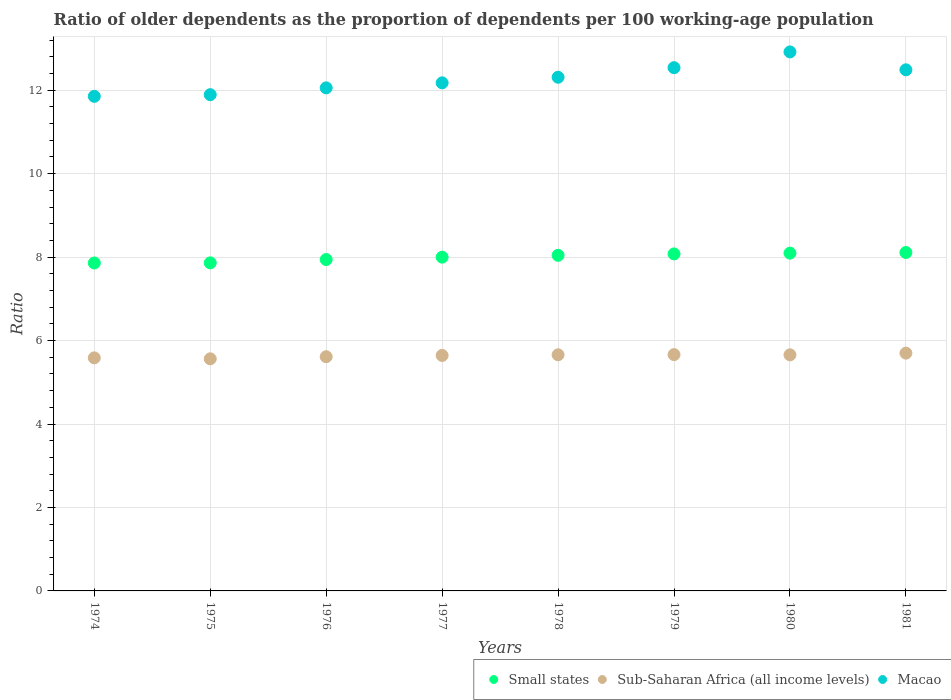How many different coloured dotlines are there?
Your answer should be compact. 3. Is the number of dotlines equal to the number of legend labels?
Offer a terse response. Yes. What is the age dependency ratio(old) in Macao in 1975?
Offer a very short reply. 11.89. Across all years, what is the maximum age dependency ratio(old) in Sub-Saharan Africa (all income levels)?
Make the answer very short. 5.7. Across all years, what is the minimum age dependency ratio(old) in Sub-Saharan Africa (all income levels)?
Ensure brevity in your answer.  5.56. In which year was the age dependency ratio(old) in Sub-Saharan Africa (all income levels) minimum?
Provide a short and direct response. 1975. What is the total age dependency ratio(old) in Sub-Saharan Africa (all income levels) in the graph?
Offer a terse response. 45.08. What is the difference between the age dependency ratio(old) in Sub-Saharan Africa (all income levels) in 1977 and that in 1980?
Your answer should be compact. -0.01. What is the difference between the age dependency ratio(old) in Sub-Saharan Africa (all income levels) in 1981 and the age dependency ratio(old) in Small states in 1974?
Give a very brief answer. -2.16. What is the average age dependency ratio(old) in Macao per year?
Your response must be concise. 12.28. In the year 1978, what is the difference between the age dependency ratio(old) in Sub-Saharan Africa (all income levels) and age dependency ratio(old) in Macao?
Provide a short and direct response. -6.65. What is the ratio of the age dependency ratio(old) in Small states in 1976 to that in 1979?
Your answer should be very brief. 0.98. Is the difference between the age dependency ratio(old) in Sub-Saharan Africa (all income levels) in 1979 and 1980 greater than the difference between the age dependency ratio(old) in Macao in 1979 and 1980?
Provide a succinct answer. Yes. What is the difference between the highest and the second highest age dependency ratio(old) in Sub-Saharan Africa (all income levels)?
Your answer should be very brief. 0.04. What is the difference between the highest and the lowest age dependency ratio(old) in Small states?
Offer a terse response. 0.25. In how many years, is the age dependency ratio(old) in Macao greater than the average age dependency ratio(old) in Macao taken over all years?
Ensure brevity in your answer.  4. Is the sum of the age dependency ratio(old) in Sub-Saharan Africa (all income levels) in 1974 and 1980 greater than the maximum age dependency ratio(old) in Small states across all years?
Keep it short and to the point. Yes. Is it the case that in every year, the sum of the age dependency ratio(old) in Sub-Saharan Africa (all income levels) and age dependency ratio(old) in Macao  is greater than the age dependency ratio(old) in Small states?
Ensure brevity in your answer.  Yes. Does the age dependency ratio(old) in Small states monotonically increase over the years?
Keep it short and to the point. Yes. Is the age dependency ratio(old) in Sub-Saharan Africa (all income levels) strictly greater than the age dependency ratio(old) in Small states over the years?
Give a very brief answer. No. How many years are there in the graph?
Provide a succinct answer. 8. Where does the legend appear in the graph?
Your answer should be very brief. Bottom right. How are the legend labels stacked?
Give a very brief answer. Horizontal. What is the title of the graph?
Keep it short and to the point. Ratio of older dependents as the proportion of dependents per 100 working-age population. Does "Other small states" appear as one of the legend labels in the graph?
Make the answer very short. No. What is the label or title of the X-axis?
Your answer should be compact. Years. What is the label or title of the Y-axis?
Offer a very short reply. Ratio. What is the Ratio in Small states in 1974?
Make the answer very short. 7.86. What is the Ratio of Sub-Saharan Africa (all income levels) in 1974?
Offer a terse response. 5.59. What is the Ratio of Macao in 1974?
Provide a succinct answer. 11.85. What is the Ratio in Small states in 1975?
Your response must be concise. 7.86. What is the Ratio in Sub-Saharan Africa (all income levels) in 1975?
Offer a very short reply. 5.56. What is the Ratio of Macao in 1975?
Your response must be concise. 11.89. What is the Ratio in Small states in 1976?
Provide a succinct answer. 7.94. What is the Ratio of Sub-Saharan Africa (all income levels) in 1976?
Give a very brief answer. 5.61. What is the Ratio of Macao in 1976?
Offer a very short reply. 12.06. What is the Ratio in Small states in 1977?
Provide a succinct answer. 8. What is the Ratio in Sub-Saharan Africa (all income levels) in 1977?
Make the answer very short. 5.64. What is the Ratio of Macao in 1977?
Provide a short and direct response. 12.18. What is the Ratio of Small states in 1978?
Your answer should be compact. 8.04. What is the Ratio of Sub-Saharan Africa (all income levels) in 1978?
Offer a very short reply. 5.66. What is the Ratio of Macao in 1978?
Your answer should be compact. 12.31. What is the Ratio of Small states in 1979?
Keep it short and to the point. 8.08. What is the Ratio in Sub-Saharan Africa (all income levels) in 1979?
Your answer should be compact. 5.66. What is the Ratio of Macao in 1979?
Offer a terse response. 12.54. What is the Ratio in Small states in 1980?
Keep it short and to the point. 8.1. What is the Ratio of Sub-Saharan Africa (all income levels) in 1980?
Ensure brevity in your answer.  5.66. What is the Ratio of Macao in 1980?
Provide a short and direct response. 12.92. What is the Ratio in Small states in 1981?
Give a very brief answer. 8.11. What is the Ratio in Sub-Saharan Africa (all income levels) in 1981?
Ensure brevity in your answer.  5.7. What is the Ratio of Macao in 1981?
Offer a terse response. 12.49. Across all years, what is the maximum Ratio of Small states?
Provide a short and direct response. 8.11. Across all years, what is the maximum Ratio in Sub-Saharan Africa (all income levels)?
Your answer should be compact. 5.7. Across all years, what is the maximum Ratio in Macao?
Give a very brief answer. 12.92. Across all years, what is the minimum Ratio in Small states?
Keep it short and to the point. 7.86. Across all years, what is the minimum Ratio of Sub-Saharan Africa (all income levels)?
Offer a terse response. 5.56. Across all years, what is the minimum Ratio in Macao?
Ensure brevity in your answer.  11.85. What is the total Ratio in Small states in the graph?
Give a very brief answer. 63.99. What is the total Ratio of Sub-Saharan Africa (all income levels) in the graph?
Your response must be concise. 45.08. What is the total Ratio of Macao in the graph?
Your answer should be compact. 98.24. What is the difference between the Ratio of Small states in 1974 and that in 1975?
Your answer should be compact. -0. What is the difference between the Ratio of Sub-Saharan Africa (all income levels) in 1974 and that in 1975?
Provide a succinct answer. 0.02. What is the difference between the Ratio in Macao in 1974 and that in 1975?
Offer a very short reply. -0.04. What is the difference between the Ratio in Small states in 1974 and that in 1976?
Offer a terse response. -0.08. What is the difference between the Ratio of Sub-Saharan Africa (all income levels) in 1974 and that in 1976?
Offer a terse response. -0.03. What is the difference between the Ratio of Macao in 1974 and that in 1976?
Give a very brief answer. -0.2. What is the difference between the Ratio in Small states in 1974 and that in 1977?
Your response must be concise. -0.14. What is the difference between the Ratio in Sub-Saharan Africa (all income levels) in 1974 and that in 1977?
Your answer should be very brief. -0.06. What is the difference between the Ratio of Macao in 1974 and that in 1977?
Offer a very short reply. -0.32. What is the difference between the Ratio of Small states in 1974 and that in 1978?
Keep it short and to the point. -0.18. What is the difference between the Ratio in Sub-Saharan Africa (all income levels) in 1974 and that in 1978?
Make the answer very short. -0.07. What is the difference between the Ratio of Macao in 1974 and that in 1978?
Offer a terse response. -0.46. What is the difference between the Ratio of Small states in 1974 and that in 1979?
Keep it short and to the point. -0.22. What is the difference between the Ratio of Sub-Saharan Africa (all income levels) in 1974 and that in 1979?
Offer a terse response. -0.08. What is the difference between the Ratio of Macao in 1974 and that in 1979?
Your answer should be very brief. -0.69. What is the difference between the Ratio of Small states in 1974 and that in 1980?
Make the answer very short. -0.24. What is the difference between the Ratio in Sub-Saharan Africa (all income levels) in 1974 and that in 1980?
Your answer should be compact. -0.07. What is the difference between the Ratio in Macao in 1974 and that in 1980?
Give a very brief answer. -1.06. What is the difference between the Ratio in Small states in 1974 and that in 1981?
Offer a terse response. -0.25. What is the difference between the Ratio of Sub-Saharan Africa (all income levels) in 1974 and that in 1981?
Offer a terse response. -0.11. What is the difference between the Ratio of Macao in 1974 and that in 1981?
Your response must be concise. -0.64. What is the difference between the Ratio of Small states in 1975 and that in 1976?
Provide a succinct answer. -0.08. What is the difference between the Ratio in Sub-Saharan Africa (all income levels) in 1975 and that in 1976?
Provide a succinct answer. -0.05. What is the difference between the Ratio of Macao in 1975 and that in 1976?
Your answer should be very brief. -0.16. What is the difference between the Ratio of Small states in 1975 and that in 1977?
Provide a short and direct response. -0.14. What is the difference between the Ratio in Sub-Saharan Africa (all income levels) in 1975 and that in 1977?
Give a very brief answer. -0.08. What is the difference between the Ratio in Macao in 1975 and that in 1977?
Ensure brevity in your answer.  -0.28. What is the difference between the Ratio in Small states in 1975 and that in 1978?
Your answer should be very brief. -0.18. What is the difference between the Ratio of Sub-Saharan Africa (all income levels) in 1975 and that in 1978?
Offer a terse response. -0.1. What is the difference between the Ratio of Macao in 1975 and that in 1978?
Your answer should be very brief. -0.42. What is the difference between the Ratio in Small states in 1975 and that in 1979?
Give a very brief answer. -0.21. What is the difference between the Ratio in Sub-Saharan Africa (all income levels) in 1975 and that in 1979?
Provide a succinct answer. -0.1. What is the difference between the Ratio in Macao in 1975 and that in 1979?
Keep it short and to the point. -0.65. What is the difference between the Ratio in Small states in 1975 and that in 1980?
Offer a terse response. -0.23. What is the difference between the Ratio of Sub-Saharan Africa (all income levels) in 1975 and that in 1980?
Offer a very short reply. -0.1. What is the difference between the Ratio of Macao in 1975 and that in 1980?
Give a very brief answer. -1.02. What is the difference between the Ratio in Small states in 1975 and that in 1981?
Provide a short and direct response. -0.25. What is the difference between the Ratio in Sub-Saharan Africa (all income levels) in 1975 and that in 1981?
Keep it short and to the point. -0.14. What is the difference between the Ratio in Macao in 1975 and that in 1981?
Your answer should be very brief. -0.6. What is the difference between the Ratio in Small states in 1976 and that in 1977?
Your answer should be compact. -0.06. What is the difference between the Ratio of Sub-Saharan Africa (all income levels) in 1976 and that in 1977?
Provide a short and direct response. -0.03. What is the difference between the Ratio of Macao in 1976 and that in 1977?
Keep it short and to the point. -0.12. What is the difference between the Ratio in Small states in 1976 and that in 1978?
Make the answer very short. -0.1. What is the difference between the Ratio of Sub-Saharan Africa (all income levels) in 1976 and that in 1978?
Keep it short and to the point. -0.05. What is the difference between the Ratio of Macao in 1976 and that in 1978?
Your answer should be compact. -0.25. What is the difference between the Ratio of Small states in 1976 and that in 1979?
Your response must be concise. -0.14. What is the difference between the Ratio of Sub-Saharan Africa (all income levels) in 1976 and that in 1979?
Offer a very short reply. -0.05. What is the difference between the Ratio of Macao in 1976 and that in 1979?
Give a very brief answer. -0.48. What is the difference between the Ratio in Small states in 1976 and that in 1980?
Your response must be concise. -0.15. What is the difference between the Ratio of Sub-Saharan Africa (all income levels) in 1976 and that in 1980?
Provide a succinct answer. -0.04. What is the difference between the Ratio of Macao in 1976 and that in 1980?
Offer a terse response. -0.86. What is the difference between the Ratio in Small states in 1976 and that in 1981?
Your response must be concise. -0.17. What is the difference between the Ratio of Sub-Saharan Africa (all income levels) in 1976 and that in 1981?
Provide a short and direct response. -0.09. What is the difference between the Ratio in Macao in 1976 and that in 1981?
Keep it short and to the point. -0.43. What is the difference between the Ratio in Small states in 1977 and that in 1978?
Your answer should be compact. -0.04. What is the difference between the Ratio of Sub-Saharan Africa (all income levels) in 1977 and that in 1978?
Give a very brief answer. -0.02. What is the difference between the Ratio in Macao in 1977 and that in 1978?
Your response must be concise. -0.13. What is the difference between the Ratio in Small states in 1977 and that in 1979?
Provide a succinct answer. -0.08. What is the difference between the Ratio of Sub-Saharan Africa (all income levels) in 1977 and that in 1979?
Your answer should be very brief. -0.02. What is the difference between the Ratio of Macao in 1977 and that in 1979?
Provide a short and direct response. -0.36. What is the difference between the Ratio of Small states in 1977 and that in 1980?
Your response must be concise. -0.1. What is the difference between the Ratio of Sub-Saharan Africa (all income levels) in 1977 and that in 1980?
Your answer should be very brief. -0.01. What is the difference between the Ratio in Macao in 1977 and that in 1980?
Give a very brief answer. -0.74. What is the difference between the Ratio of Small states in 1977 and that in 1981?
Your response must be concise. -0.11. What is the difference between the Ratio in Sub-Saharan Africa (all income levels) in 1977 and that in 1981?
Your answer should be very brief. -0.06. What is the difference between the Ratio of Macao in 1977 and that in 1981?
Your answer should be very brief. -0.31. What is the difference between the Ratio of Small states in 1978 and that in 1979?
Your answer should be very brief. -0.03. What is the difference between the Ratio of Sub-Saharan Africa (all income levels) in 1978 and that in 1979?
Your response must be concise. -0. What is the difference between the Ratio in Macao in 1978 and that in 1979?
Offer a very short reply. -0.23. What is the difference between the Ratio in Small states in 1978 and that in 1980?
Keep it short and to the point. -0.05. What is the difference between the Ratio in Sub-Saharan Africa (all income levels) in 1978 and that in 1980?
Keep it short and to the point. 0. What is the difference between the Ratio in Macao in 1978 and that in 1980?
Your response must be concise. -0.61. What is the difference between the Ratio in Small states in 1978 and that in 1981?
Offer a terse response. -0.07. What is the difference between the Ratio of Sub-Saharan Africa (all income levels) in 1978 and that in 1981?
Your answer should be compact. -0.04. What is the difference between the Ratio in Macao in 1978 and that in 1981?
Give a very brief answer. -0.18. What is the difference between the Ratio in Small states in 1979 and that in 1980?
Ensure brevity in your answer.  -0.02. What is the difference between the Ratio in Sub-Saharan Africa (all income levels) in 1979 and that in 1980?
Your answer should be compact. 0.01. What is the difference between the Ratio of Macao in 1979 and that in 1980?
Offer a very short reply. -0.38. What is the difference between the Ratio of Small states in 1979 and that in 1981?
Your answer should be compact. -0.03. What is the difference between the Ratio of Sub-Saharan Africa (all income levels) in 1979 and that in 1981?
Provide a short and direct response. -0.04. What is the difference between the Ratio of Macao in 1979 and that in 1981?
Offer a very short reply. 0.05. What is the difference between the Ratio in Small states in 1980 and that in 1981?
Make the answer very short. -0.02. What is the difference between the Ratio in Sub-Saharan Africa (all income levels) in 1980 and that in 1981?
Your answer should be very brief. -0.04. What is the difference between the Ratio in Macao in 1980 and that in 1981?
Make the answer very short. 0.43. What is the difference between the Ratio of Small states in 1974 and the Ratio of Sub-Saharan Africa (all income levels) in 1975?
Ensure brevity in your answer.  2.3. What is the difference between the Ratio of Small states in 1974 and the Ratio of Macao in 1975?
Give a very brief answer. -4.03. What is the difference between the Ratio of Sub-Saharan Africa (all income levels) in 1974 and the Ratio of Macao in 1975?
Make the answer very short. -6.31. What is the difference between the Ratio in Small states in 1974 and the Ratio in Sub-Saharan Africa (all income levels) in 1976?
Ensure brevity in your answer.  2.25. What is the difference between the Ratio in Small states in 1974 and the Ratio in Macao in 1976?
Your answer should be very brief. -4.2. What is the difference between the Ratio of Sub-Saharan Africa (all income levels) in 1974 and the Ratio of Macao in 1976?
Your answer should be compact. -6.47. What is the difference between the Ratio of Small states in 1974 and the Ratio of Sub-Saharan Africa (all income levels) in 1977?
Make the answer very short. 2.22. What is the difference between the Ratio of Small states in 1974 and the Ratio of Macao in 1977?
Give a very brief answer. -4.32. What is the difference between the Ratio of Sub-Saharan Africa (all income levels) in 1974 and the Ratio of Macao in 1977?
Keep it short and to the point. -6.59. What is the difference between the Ratio of Small states in 1974 and the Ratio of Sub-Saharan Africa (all income levels) in 1978?
Give a very brief answer. 2.2. What is the difference between the Ratio of Small states in 1974 and the Ratio of Macao in 1978?
Offer a terse response. -4.45. What is the difference between the Ratio of Sub-Saharan Africa (all income levels) in 1974 and the Ratio of Macao in 1978?
Provide a short and direct response. -6.73. What is the difference between the Ratio in Small states in 1974 and the Ratio in Sub-Saharan Africa (all income levels) in 1979?
Ensure brevity in your answer.  2.2. What is the difference between the Ratio of Small states in 1974 and the Ratio of Macao in 1979?
Offer a very short reply. -4.68. What is the difference between the Ratio of Sub-Saharan Africa (all income levels) in 1974 and the Ratio of Macao in 1979?
Give a very brief answer. -6.95. What is the difference between the Ratio of Small states in 1974 and the Ratio of Sub-Saharan Africa (all income levels) in 1980?
Ensure brevity in your answer.  2.2. What is the difference between the Ratio in Small states in 1974 and the Ratio in Macao in 1980?
Make the answer very short. -5.06. What is the difference between the Ratio of Sub-Saharan Africa (all income levels) in 1974 and the Ratio of Macao in 1980?
Offer a very short reply. -7.33. What is the difference between the Ratio in Small states in 1974 and the Ratio in Sub-Saharan Africa (all income levels) in 1981?
Offer a very short reply. 2.16. What is the difference between the Ratio of Small states in 1974 and the Ratio of Macao in 1981?
Offer a very short reply. -4.63. What is the difference between the Ratio in Sub-Saharan Africa (all income levels) in 1974 and the Ratio in Macao in 1981?
Offer a terse response. -6.9. What is the difference between the Ratio in Small states in 1975 and the Ratio in Sub-Saharan Africa (all income levels) in 1976?
Provide a succinct answer. 2.25. What is the difference between the Ratio in Small states in 1975 and the Ratio in Macao in 1976?
Your response must be concise. -4.19. What is the difference between the Ratio of Sub-Saharan Africa (all income levels) in 1975 and the Ratio of Macao in 1976?
Provide a succinct answer. -6.49. What is the difference between the Ratio of Small states in 1975 and the Ratio of Sub-Saharan Africa (all income levels) in 1977?
Offer a very short reply. 2.22. What is the difference between the Ratio of Small states in 1975 and the Ratio of Macao in 1977?
Ensure brevity in your answer.  -4.31. What is the difference between the Ratio of Sub-Saharan Africa (all income levels) in 1975 and the Ratio of Macao in 1977?
Your answer should be compact. -6.61. What is the difference between the Ratio in Small states in 1975 and the Ratio in Sub-Saharan Africa (all income levels) in 1978?
Your answer should be very brief. 2.2. What is the difference between the Ratio of Small states in 1975 and the Ratio of Macao in 1978?
Provide a short and direct response. -4.45. What is the difference between the Ratio of Sub-Saharan Africa (all income levels) in 1975 and the Ratio of Macao in 1978?
Offer a very short reply. -6.75. What is the difference between the Ratio of Small states in 1975 and the Ratio of Sub-Saharan Africa (all income levels) in 1979?
Offer a very short reply. 2.2. What is the difference between the Ratio of Small states in 1975 and the Ratio of Macao in 1979?
Provide a short and direct response. -4.68. What is the difference between the Ratio in Sub-Saharan Africa (all income levels) in 1975 and the Ratio in Macao in 1979?
Provide a short and direct response. -6.98. What is the difference between the Ratio in Small states in 1975 and the Ratio in Sub-Saharan Africa (all income levels) in 1980?
Ensure brevity in your answer.  2.2. What is the difference between the Ratio in Small states in 1975 and the Ratio in Macao in 1980?
Keep it short and to the point. -5.06. What is the difference between the Ratio in Sub-Saharan Africa (all income levels) in 1975 and the Ratio in Macao in 1980?
Provide a succinct answer. -7.36. What is the difference between the Ratio in Small states in 1975 and the Ratio in Sub-Saharan Africa (all income levels) in 1981?
Ensure brevity in your answer.  2.16. What is the difference between the Ratio in Small states in 1975 and the Ratio in Macao in 1981?
Provide a short and direct response. -4.63. What is the difference between the Ratio in Sub-Saharan Africa (all income levels) in 1975 and the Ratio in Macao in 1981?
Provide a short and direct response. -6.93. What is the difference between the Ratio of Small states in 1976 and the Ratio of Sub-Saharan Africa (all income levels) in 1977?
Keep it short and to the point. 2.3. What is the difference between the Ratio in Small states in 1976 and the Ratio in Macao in 1977?
Provide a succinct answer. -4.24. What is the difference between the Ratio of Sub-Saharan Africa (all income levels) in 1976 and the Ratio of Macao in 1977?
Ensure brevity in your answer.  -6.56. What is the difference between the Ratio in Small states in 1976 and the Ratio in Sub-Saharan Africa (all income levels) in 1978?
Your answer should be very brief. 2.28. What is the difference between the Ratio of Small states in 1976 and the Ratio of Macao in 1978?
Give a very brief answer. -4.37. What is the difference between the Ratio of Sub-Saharan Africa (all income levels) in 1976 and the Ratio of Macao in 1978?
Ensure brevity in your answer.  -6.7. What is the difference between the Ratio in Small states in 1976 and the Ratio in Sub-Saharan Africa (all income levels) in 1979?
Provide a short and direct response. 2.28. What is the difference between the Ratio of Small states in 1976 and the Ratio of Macao in 1979?
Your answer should be very brief. -4.6. What is the difference between the Ratio in Sub-Saharan Africa (all income levels) in 1976 and the Ratio in Macao in 1979?
Make the answer very short. -6.93. What is the difference between the Ratio of Small states in 1976 and the Ratio of Sub-Saharan Africa (all income levels) in 1980?
Keep it short and to the point. 2.28. What is the difference between the Ratio in Small states in 1976 and the Ratio in Macao in 1980?
Ensure brevity in your answer.  -4.98. What is the difference between the Ratio of Sub-Saharan Africa (all income levels) in 1976 and the Ratio of Macao in 1980?
Offer a terse response. -7.31. What is the difference between the Ratio of Small states in 1976 and the Ratio of Sub-Saharan Africa (all income levels) in 1981?
Provide a short and direct response. 2.24. What is the difference between the Ratio of Small states in 1976 and the Ratio of Macao in 1981?
Your answer should be compact. -4.55. What is the difference between the Ratio of Sub-Saharan Africa (all income levels) in 1976 and the Ratio of Macao in 1981?
Offer a terse response. -6.88. What is the difference between the Ratio in Small states in 1977 and the Ratio in Sub-Saharan Africa (all income levels) in 1978?
Offer a very short reply. 2.34. What is the difference between the Ratio in Small states in 1977 and the Ratio in Macao in 1978?
Your answer should be compact. -4.31. What is the difference between the Ratio of Sub-Saharan Africa (all income levels) in 1977 and the Ratio of Macao in 1978?
Provide a succinct answer. -6.67. What is the difference between the Ratio in Small states in 1977 and the Ratio in Sub-Saharan Africa (all income levels) in 1979?
Your answer should be compact. 2.34. What is the difference between the Ratio of Small states in 1977 and the Ratio of Macao in 1979?
Keep it short and to the point. -4.54. What is the difference between the Ratio of Sub-Saharan Africa (all income levels) in 1977 and the Ratio of Macao in 1979?
Provide a succinct answer. -6.9. What is the difference between the Ratio of Small states in 1977 and the Ratio of Sub-Saharan Africa (all income levels) in 1980?
Your answer should be very brief. 2.34. What is the difference between the Ratio in Small states in 1977 and the Ratio in Macao in 1980?
Offer a terse response. -4.92. What is the difference between the Ratio of Sub-Saharan Africa (all income levels) in 1977 and the Ratio of Macao in 1980?
Offer a terse response. -7.27. What is the difference between the Ratio of Small states in 1977 and the Ratio of Sub-Saharan Africa (all income levels) in 1981?
Give a very brief answer. 2.3. What is the difference between the Ratio of Small states in 1977 and the Ratio of Macao in 1981?
Your answer should be compact. -4.49. What is the difference between the Ratio of Sub-Saharan Africa (all income levels) in 1977 and the Ratio of Macao in 1981?
Make the answer very short. -6.85. What is the difference between the Ratio of Small states in 1978 and the Ratio of Sub-Saharan Africa (all income levels) in 1979?
Give a very brief answer. 2.38. What is the difference between the Ratio of Small states in 1978 and the Ratio of Macao in 1979?
Your answer should be very brief. -4.5. What is the difference between the Ratio of Sub-Saharan Africa (all income levels) in 1978 and the Ratio of Macao in 1979?
Give a very brief answer. -6.88. What is the difference between the Ratio of Small states in 1978 and the Ratio of Sub-Saharan Africa (all income levels) in 1980?
Make the answer very short. 2.39. What is the difference between the Ratio of Small states in 1978 and the Ratio of Macao in 1980?
Provide a short and direct response. -4.87. What is the difference between the Ratio of Sub-Saharan Africa (all income levels) in 1978 and the Ratio of Macao in 1980?
Your answer should be very brief. -7.26. What is the difference between the Ratio of Small states in 1978 and the Ratio of Sub-Saharan Africa (all income levels) in 1981?
Your answer should be compact. 2.34. What is the difference between the Ratio of Small states in 1978 and the Ratio of Macao in 1981?
Give a very brief answer. -4.45. What is the difference between the Ratio of Sub-Saharan Africa (all income levels) in 1978 and the Ratio of Macao in 1981?
Provide a succinct answer. -6.83. What is the difference between the Ratio of Small states in 1979 and the Ratio of Sub-Saharan Africa (all income levels) in 1980?
Provide a short and direct response. 2.42. What is the difference between the Ratio of Small states in 1979 and the Ratio of Macao in 1980?
Your response must be concise. -4.84. What is the difference between the Ratio in Sub-Saharan Africa (all income levels) in 1979 and the Ratio in Macao in 1980?
Offer a very short reply. -7.25. What is the difference between the Ratio of Small states in 1979 and the Ratio of Sub-Saharan Africa (all income levels) in 1981?
Provide a succinct answer. 2.38. What is the difference between the Ratio of Small states in 1979 and the Ratio of Macao in 1981?
Provide a short and direct response. -4.41. What is the difference between the Ratio of Sub-Saharan Africa (all income levels) in 1979 and the Ratio of Macao in 1981?
Ensure brevity in your answer.  -6.83. What is the difference between the Ratio in Small states in 1980 and the Ratio in Sub-Saharan Africa (all income levels) in 1981?
Provide a succinct answer. 2.4. What is the difference between the Ratio in Small states in 1980 and the Ratio in Macao in 1981?
Your answer should be compact. -4.39. What is the difference between the Ratio in Sub-Saharan Africa (all income levels) in 1980 and the Ratio in Macao in 1981?
Ensure brevity in your answer.  -6.83. What is the average Ratio in Small states per year?
Your answer should be very brief. 8. What is the average Ratio in Sub-Saharan Africa (all income levels) per year?
Make the answer very short. 5.64. What is the average Ratio in Macao per year?
Provide a short and direct response. 12.28. In the year 1974, what is the difference between the Ratio of Small states and Ratio of Sub-Saharan Africa (all income levels)?
Ensure brevity in your answer.  2.27. In the year 1974, what is the difference between the Ratio of Small states and Ratio of Macao?
Offer a very short reply. -3.99. In the year 1974, what is the difference between the Ratio in Sub-Saharan Africa (all income levels) and Ratio in Macao?
Make the answer very short. -6.27. In the year 1975, what is the difference between the Ratio in Small states and Ratio in Sub-Saharan Africa (all income levels)?
Make the answer very short. 2.3. In the year 1975, what is the difference between the Ratio in Small states and Ratio in Macao?
Your answer should be compact. -4.03. In the year 1975, what is the difference between the Ratio of Sub-Saharan Africa (all income levels) and Ratio of Macao?
Your response must be concise. -6.33. In the year 1976, what is the difference between the Ratio in Small states and Ratio in Sub-Saharan Africa (all income levels)?
Provide a short and direct response. 2.33. In the year 1976, what is the difference between the Ratio of Small states and Ratio of Macao?
Your answer should be very brief. -4.11. In the year 1976, what is the difference between the Ratio in Sub-Saharan Africa (all income levels) and Ratio in Macao?
Your response must be concise. -6.44. In the year 1977, what is the difference between the Ratio of Small states and Ratio of Sub-Saharan Africa (all income levels)?
Provide a short and direct response. 2.36. In the year 1977, what is the difference between the Ratio of Small states and Ratio of Macao?
Offer a terse response. -4.18. In the year 1977, what is the difference between the Ratio in Sub-Saharan Africa (all income levels) and Ratio in Macao?
Your answer should be compact. -6.53. In the year 1978, what is the difference between the Ratio of Small states and Ratio of Sub-Saharan Africa (all income levels)?
Give a very brief answer. 2.38. In the year 1978, what is the difference between the Ratio of Small states and Ratio of Macao?
Keep it short and to the point. -4.27. In the year 1978, what is the difference between the Ratio in Sub-Saharan Africa (all income levels) and Ratio in Macao?
Your response must be concise. -6.65. In the year 1979, what is the difference between the Ratio of Small states and Ratio of Sub-Saharan Africa (all income levels)?
Your answer should be very brief. 2.41. In the year 1979, what is the difference between the Ratio of Small states and Ratio of Macao?
Offer a very short reply. -4.46. In the year 1979, what is the difference between the Ratio in Sub-Saharan Africa (all income levels) and Ratio in Macao?
Your answer should be compact. -6.88. In the year 1980, what is the difference between the Ratio of Small states and Ratio of Sub-Saharan Africa (all income levels)?
Offer a very short reply. 2.44. In the year 1980, what is the difference between the Ratio in Small states and Ratio in Macao?
Your answer should be compact. -4.82. In the year 1980, what is the difference between the Ratio in Sub-Saharan Africa (all income levels) and Ratio in Macao?
Keep it short and to the point. -7.26. In the year 1981, what is the difference between the Ratio in Small states and Ratio in Sub-Saharan Africa (all income levels)?
Provide a short and direct response. 2.41. In the year 1981, what is the difference between the Ratio in Small states and Ratio in Macao?
Give a very brief answer. -4.38. In the year 1981, what is the difference between the Ratio of Sub-Saharan Africa (all income levels) and Ratio of Macao?
Offer a terse response. -6.79. What is the ratio of the Ratio of Macao in 1974 to that in 1976?
Make the answer very short. 0.98. What is the ratio of the Ratio of Small states in 1974 to that in 1977?
Your answer should be very brief. 0.98. What is the ratio of the Ratio in Macao in 1974 to that in 1977?
Your answer should be compact. 0.97. What is the ratio of the Ratio in Small states in 1974 to that in 1978?
Make the answer very short. 0.98. What is the ratio of the Ratio of Sub-Saharan Africa (all income levels) in 1974 to that in 1978?
Provide a short and direct response. 0.99. What is the ratio of the Ratio of Macao in 1974 to that in 1978?
Your answer should be compact. 0.96. What is the ratio of the Ratio in Small states in 1974 to that in 1979?
Your response must be concise. 0.97. What is the ratio of the Ratio of Sub-Saharan Africa (all income levels) in 1974 to that in 1979?
Make the answer very short. 0.99. What is the ratio of the Ratio of Macao in 1974 to that in 1979?
Ensure brevity in your answer.  0.95. What is the ratio of the Ratio in Small states in 1974 to that in 1980?
Make the answer very short. 0.97. What is the ratio of the Ratio in Sub-Saharan Africa (all income levels) in 1974 to that in 1980?
Your response must be concise. 0.99. What is the ratio of the Ratio in Macao in 1974 to that in 1980?
Provide a succinct answer. 0.92. What is the ratio of the Ratio in Sub-Saharan Africa (all income levels) in 1974 to that in 1981?
Offer a terse response. 0.98. What is the ratio of the Ratio of Macao in 1974 to that in 1981?
Ensure brevity in your answer.  0.95. What is the ratio of the Ratio in Small states in 1975 to that in 1976?
Ensure brevity in your answer.  0.99. What is the ratio of the Ratio of Macao in 1975 to that in 1976?
Make the answer very short. 0.99. What is the ratio of the Ratio in Small states in 1975 to that in 1977?
Your answer should be compact. 0.98. What is the ratio of the Ratio of Sub-Saharan Africa (all income levels) in 1975 to that in 1977?
Keep it short and to the point. 0.99. What is the ratio of the Ratio of Macao in 1975 to that in 1977?
Keep it short and to the point. 0.98. What is the ratio of the Ratio of Small states in 1975 to that in 1978?
Keep it short and to the point. 0.98. What is the ratio of the Ratio of Macao in 1975 to that in 1978?
Ensure brevity in your answer.  0.97. What is the ratio of the Ratio in Small states in 1975 to that in 1979?
Ensure brevity in your answer.  0.97. What is the ratio of the Ratio of Sub-Saharan Africa (all income levels) in 1975 to that in 1979?
Keep it short and to the point. 0.98. What is the ratio of the Ratio in Macao in 1975 to that in 1979?
Offer a terse response. 0.95. What is the ratio of the Ratio of Small states in 1975 to that in 1980?
Offer a terse response. 0.97. What is the ratio of the Ratio of Sub-Saharan Africa (all income levels) in 1975 to that in 1980?
Provide a short and direct response. 0.98. What is the ratio of the Ratio in Macao in 1975 to that in 1980?
Keep it short and to the point. 0.92. What is the ratio of the Ratio in Small states in 1975 to that in 1981?
Your response must be concise. 0.97. What is the ratio of the Ratio of Sub-Saharan Africa (all income levels) in 1975 to that in 1981?
Offer a very short reply. 0.98. What is the ratio of the Ratio in Macao in 1975 to that in 1981?
Make the answer very short. 0.95. What is the ratio of the Ratio in Macao in 1976 to that in 1977?
Provide a short and direct response. 0.99. What is the ratio of the Ratio in Small states in 1976 to that in 1978?
Provide a short and direct response. 0.99. What is the ratio of the Ratio in Macao in 1976 to that in 1978?
Provide a short and direct response. 0.98. What is the ratio of the Ratio in Small states in 1976 to that in 1979?
Keep it short and to the point. 0.98. What is the ratio of the Ratio in Macao in 1976 to that in 1979?
Give a very brief answer. 0.96. What is the ratio of the Ratio in Small states in 1976 to that in 1980?
Offer a very short reply. 0.98. What is the ratio of the Ratio of Small states in 1976 to that in 1981?
Make the answer very short. 0.98. What is the ratio of the Ratio of Sub-Saharan Africa (all income levels) in 1976 to that in 1981?
Provide a short and direct response. 0.98. What is the ratio of the Ratio of Macao in 1976 to that in 1981?
Your response must be concise. 0.97. What is the ratio of the Ratio in Small states in 1977 to that in 1978?
Your response must be concise. 0.99. What is the ratio of the Ratio in Macao in 1977 to that in 1978?
Offer a very short reply. 0.99. What is the ratio of the Ratio of Small states in 1977 to that in 1979?
Provide a short and direct response. 0.99. What is the ratio of the Ratio in Macao in 1977 to that in 1979?
Give a very brief answer. 0.97. What is the ratio of the Ratio of Sub-Saharan Africa (all income levels) in 1977 to that in 1980?
Offer a terse response. 1. What is the ratio of the Ratio of Macao in 1977 to that in 1980?
Keep it short and to the point. 0.94. What is the ratio of the Ratio in Small states in 1977 to that in 1981?
Offer a very short reply. 0.99. What is the ratio of the Ratio of Sub-Saharan Africa (all income levels) in 1977 to that in 1981?
Provide a succinct answer. 0.99. What is the ratio of the Ratio of Small states in 1978 to that in 1979?
Your answer should be compact. 1. What is the ratio of the Ratio in Macao in 1978 to that in 1979?
Provide a succinct answer. 0.98. What is the ratio of the Ratio of Sub-Saharan Africa (all income levels) in 1978 to that in 1980?
Give a very brief answer. 1. What is the ratio of the Ratio of Macao in 1978 to that in 1980?
Your response must be concise. 0.95. What is the ratio of the Ratio in Small states in 1978 to that in 1981?
Your answer should be very brief. 0.99. What is the ratio of the Ratio of Macao in 1978 to that in 1981?
Give a very brief answer. 0.99. What is the ratio of the Ratio in Sub-Saharan Africa (all income levels) in 1979 to that in 1980?
Give a very brief answer. 1. What is the ratio of the Ratio of Macao in 1979 to that in 1980?
Make the answer very short. 0.97. What is the ratio of the Ratio in Macao in 1979 to that in 1981?
Offer a very short reply. 1. What is the ratio of the Ratio in Small states in 1980 to that in 1981?
Provide a succinct answer. 1. What is the ratio of the Ratio in Macao in 1980 to that in 1981?
Make the answer very short. 1.03. What is the difference between the highest and the second highest Ratio of Small states?
Offer a terse response. 0.02. What is the difference between the highest and the second highest Ratio of Sub-Saharan Africa (all income levels)?
Offer a terse response. 0.04. What is the difference between the highest and the second highest Ratio of Macao?
Give a very brief answer. 0.38. What is the difference between the highest and the lowest Ratio of Small states?
Your answer should be very brief. 0.25. What is the difference between the highest and the lowest Ratio of Sub-Saharan Africa (all income levels)?
Provide a short and direct response. 0.14. What is the difference between the highest and the lowest Ratio of Macao?
Provide a short and direct response. 1.06. 